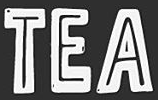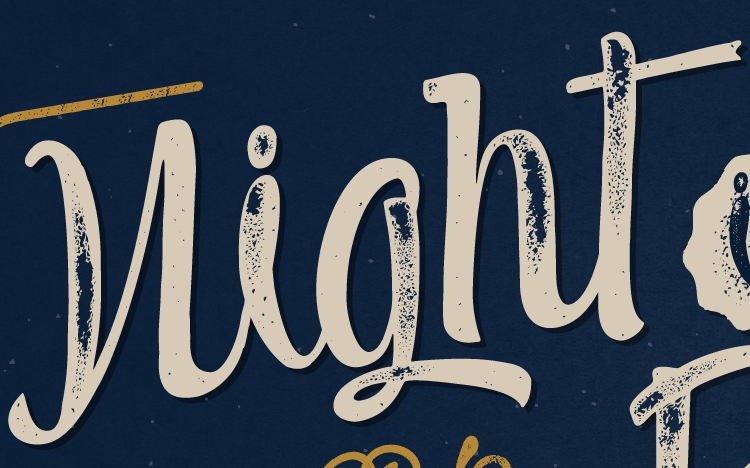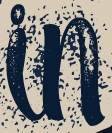Read the text content from these images in order, separated by a semicolon. TEA; night; in 